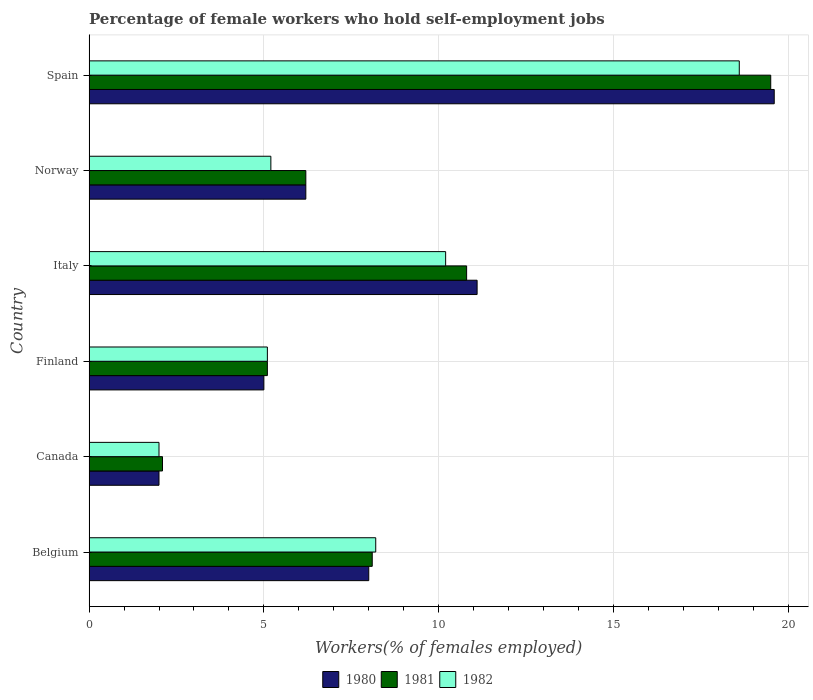How many bars are there on the 4th tick from the top?
Your answer should be compact. 3. How many bars are there on the 2nd tick from the bottom?
Offer a very short reply. 3. What is the label of the 1st group of bars from the top?
Your answer should be compact. Spain. What is the percentage of self-employed female workers in 1980 in Norway?
Provide a short and direct response. 6.2. Across all countries, what is the maximum percentage of self-employed female workers in 1980?
Make the answer very short. 19.6. Across all countries, what is the minimum percentage of self-employed female workers in 1981?
Provide a short and direct response. 2.1. In which country was the percentage of self-employed female workers in 1982 maximum?
Ensure brevity in your answer.  Spain. In which country was the percentage of self-employed female workers in 1981 minimum?
Make the answer very short. Canada. What is the total percentage of self-employed female workers in 1982 in the graph?
Provide a short and direct response. 49.3. What is the difference between the percentage of self-employed female workers in 1980 in Canada and that in Italy?
Provide a succinct answer. -9.1. What is the difference between the percentage of self-employed female workers in 1981 in Spain and the percentage of self-employed female workers in 1982 in Norway?
Your answer should be compact. 14.3. What is the average percentage of self-employed female workers in 1981 per country?
Provide a succinct answer. 8.63. In how many countries, is the percentage of self-employed female workers in 1981 greater than 4 %?
Your response must be concise. 5. What is the ratio of the percentage of self-employed female workers in 1982 in Italy to that in Norway?
Make the answer very short. 1.96. Is the percentage of self-employed female workers in 1981 in Finland less than that in Spain?
Your answer should be compact. Yes. What is the difference between the highest and the second highest percentage of self-employed female workers in 1981?
Provide a short and direct response. 8.7. What is the difference between the highest and the lowest percentage of self-employed female workers in 1982?
Your answer should be very brief. 16.6. In how many countries, is the percentage of self-employed female workers in 1982 greater than the average percentage of self-employed female workers in 1982 taken over all countries?
Your answer should be compact. 2. Is the sum of the percentage of self-employed female workers in 1982 in Norway and Spain greater than the maximum percentage of self-employed female workers in 1981 across all countries?
Keep it short and to the point. Yes. What does the 2nd bar from the top in Italy represents?
Make the answer very short. 1981. What does the 3rd bar from the bottom in Norway represents?
Make the answer very short. 1982. How many countries are there in the graph?
Make the answer very short. 6. Are the values on the major ticks of X-axis written in scientific E-notation?
Offer a terse response. No. Does the graph contain grids?
Make the answer very short. Yes. How many legend labels are there?
Your answer should be compact. 3. How are the legend labels stacked?
Provide a short and direct response. Horizontal. What is the title of the graph?
Your answer should be very brief. Percentage of female workers who hold self-employment jobs. Does "2009" appear as one of the legend labels in the graph?
Provide a succinct answer. No. What is the label or title of the X-axis?
Offer a terse response. Workers(% of females employed). What is the label or title of the Y-axis?
Ensure brevity in your answer.  Country. What is the Workers(% of females employed) of 1981 in Belgium?
Your response must be concise. 8.1. What is the Workers(% of females employed) in 1982 in Belgium?
Give a very brief answer. 8.2. What is the Workers(% of females employed) in 1980 in Canada?
Your response must be concise. 2. What is the Workers(% of females employed) in 1981 in Canada?
Offer a terse response. 2.1. What is the Workers(% of females employed) in 1981 in Finland?
Provide a succinct answer. 5.1. What is the Workers(% of females employed) in 1982 in Finland?
Provide a succinct answer. 5.1. What is the Workers(% of females employed) of 1980 in Italy?
Your answer should be compact. 11.1. What is the Workers(% of females employed) in 1981 in Italy?
Ensure brevity in your answer.  10.8. What is the Workers(% of females employed) of 1982 in Italy?
Offer a very short reply. 10.2. What is the Workers(% of females employed) of 1980 in Norway?
Ensure brevity in your answer.  6.2. What is the Workers(% of females employed) of 1981 in Norway?
Provide a short and direct response. 6.2. What is the Workers(% of females employed) in 1982 in Norway?
Ensure brevity in your answer.  5.2. What is the Workers(% of females employed) in 1980 in Spain?
Offer a terse response. 19.6. What is the Workers(% of females employed) in 1981 in Spain?
Provide a short and direct response. 19.5. What is the Workers(% of females employed) in 1982 in Spain?
Provide a short and direct response. 18.6. Across all countries, what is the maximum Workers(% of females employed) in 1980?
Make the answer very short. 19.6. Across all countries, what is the maximum Workers(% of females employed) in 1982?
Your answer should be very brief. 18.6. Across all countries, what is the minimum Workers(% of females employed) in 1981?
Make the answer very short. 2.1. Across all countries, what is the minimum Workers(% of females employed) in 1982?
Give a very brief answer. 2. What is the total Workers(% of females employed) in 1980 in the graph?
Keep it short and to the point. 51.9. What is the total Workers(% of females employed) in 1981 in the graph?
Ensure brevity in your answer.  51.8. What is the total Workers(% of females employed) of 1982 in the graph?
Your answer should be compact. 49.3. What is the difference between the Workers(% of females employed) of 1982 in Belgium and that in Canada?
Keep it short and to the point. 6.2. What is the difference between the Workers(% of females employed) of 1982 in Belgium and that in Finland?
Offer a very short reply. 3.1. What is the difference between the Workers(% of females employed) of 1981 in Belgium and that in Italy?
Give a very brief answer. -2.7. What is the difference between the Workers(% of females employed) in 1982 in Belgium and that in Italy?
Your answer should be very brief. -2. What is the difference between the Workers(% of females employed) in 1980 in Belgium and that in Norway?
Make the answer very short. 1.8. What is the difference between the Workers(% of females employed) in 1980 in Belgium and that in Spain?
Provide a short and direct response. -11.6. What is the difference between the Workers(% of females employed) in 1981 in Belgium and that in Spain?
Ensure brevity in your answer.  -11.4. What is the difference between the Workers(% of females employed) in 1982 in Belgium and that in Spain?
Your answer should be compact. -10.4. What is the difference between the Workers(% of females employed) in 1980 in Canada and that in Finland?
Offer a very short reply. -3. What is the difference between the Workers(% of females employed) in 1982 in Canada and that in Finland?
Give a very brief answer. -3.1. What is the difference between the Workers(% of females employed) in 1981 in Canada and that in Italy?
Offer a very short reply. -8.7. What is the difference between the Workers(% of females employed) in 1982 in Canada and that in Italy?
Keep it short and to the point. -8.2. What is the difference between the Workers(% of females employed) of 1982 in Canada and that in Norway?
Make the answer very short. -3.2. What is the difference between the Workers(% of females employed) in 1980 in Canada and that in Spain?
Make the answer very short. -17.6. What is the difference between the Workers(% of females employed) in 1981 in Canada and that in Spain?
Keep it short and to the point. -17.4. What is the difference between the Workers(% of females employed) in 1982 in Canada and that in Spain?
Your response must be concise. -16.6. What is the difference between the Workers(% of females employed) in 1981 in Finland and that in Italy?
Your answer should be very brief. -5.7. What is the difference between the Workers(% of females employed) of 1982 in Finland and that in Italy?
Offer a very short reply. -5.1. What is the difference between the Workers(% of females employed) of 1981 in Finland and that in Norway?
Give a very brief answer. -1.1. What is the difference between the Workers(% of females employed) in 1982 in Finland and that in Norway?
Offer a very short reply. -0.1. What is the difference between the Workers(% of females employed) of 1980 in Finland and that in Spain?
Provide a short and direct response. -14.6. What is the difference between the Workers(% of females employed) in 1981 in Finland and that in Spain?
Give a very brief answer. -14.4. What is the difference between the Workers(% of females employed) of 1982 in Finland and that in Spain?
Make the answer very short. -13.5. What is the difference between the Workers(% of females employed) in 1982 in Italy and that in Norway?
Give a very brief answer. 5. What is the difference between the Workers(% of females employed) in 1982 in Italy and that in Spain?
Offer a very short reply. -8.4. What is the difference between the Workers(% of females employed) in 1981 in Norway and that in Spain?
Give a very brief answer. -13.3. What is the difference between the Workers(% of females employed) of 1982 in Norway and that in Spain?
Ensure brevity in your answer.  -13.4. What is the difference between the Workers(% of females employed) in 1981 in Belgium and the Workers(% of females employed) in 1982 in Canada?
Provide a succinct answer. 6.1. What is the difference between the Workers(% of females employed) of 1981 in Belgium and the Workers(% of females employed) of 1982 in Finland?
Give a very brief answer. 3. What is the difference between the Workers(% of females employed) of 1980 in Belgium and the Workers(% of females employed) of 1981 in Italy?
Make the answer very short. -2.8. What is the difference between the Workers(% of females employed) of 1980 in Belgium and the Workers(% of females employed) of 1982 in Italy?
Your response must be concise. -2.2. What is the difference between the Workers(% of females employed) of 1981 in Belgium and the Workers(% of females employed) of 1982 in Italy?
Offer a terse response. -2.1. What is the difference between the Workers(% of females employed) in 1980 in Belgium and the Workers(% of females employed) in 1982 in Norway?
Provide a succinct answer. 2.8. What is the difference between the Workers(% of females employed) of 1980 in Belgium and the Workers(% of females employed) of 1982 in Spain?
Provide a succinct answer. -10.6. What is the difference between the Workers(% of females employed) in 1981 in Belgium and the Workers(% of females employed) in 1982 in Spain?
Offer a very short reply. -10.5. What is the difference between the Workers(% of females employed) of 1980 in Canada and the Workers(% of females employed) of 1982 in Italy?
Provide a short and direct response. -8.2. What is the difference between the Workers(% of females employed) in 1981 in Canada and the Workers(% of females employed) in 1982 in Italy?
Your answer should be very brief. -8.1. What is the difference between the Workers(% of females employed) of 1980 in Canada and the Workers(% of females employed) of 1981 in Norway?
Provide a succinct answer. -4.2. What is the difference between the Workers(% of females employed) of 1980 in Canada and the Workers(% of females employed) of 1982 in Norway?
Provide a succinct answer. -3.2. What is the difference between the Workers(% of females employed) in 1980 in Canada and the Workers(% of females employed) in 1981 in Spain?
Your answer should be compact. -17.5. What is the difference between the Workers(% of females employed) of 1980 in Canada and the Workers(% of females employed) of 1982 in Spain?
Provide a succinct answer. -16.6. What is the difference between the Workers(% of females employed) of 1981 in Canada and the Workers(% of females employed) of 1982 in Spain?
Provide a short and direct response. -16.5. What is the difference between the Workers(% of females employed) of 1980 in Finland and the Workers(% of females employed) of 1981 in Italy?
Offer a terse response. -5.8. What is the difference between the Workers(% of females employed) in 1980 in Finland and the Workers(% of females employed) in 1981 in Norway?
Your answer should be very brief. -1.2. What is the difference between the Workers(% of females employed) in 1981 in Finland and the Workers(% of females employed) in 1982 in Norway?
Your answer should be very brief. -0.1. What is the difference between the Workers(% of females employed) of 1980 in Finland and the Workers(% of females employed) of 1981 in Spain?
Your answer should be compact. -14.5. What is the difference between the Workers(% of females employed) in 1981 in Finland and the Workers(% of females employed) in 1982 in Spain?
Ensure brevity in your answer.  -13.5. What is the difference between the Workers(% of females employed) of 1980 in Italy and the Workers(% of females employed) of 1981 in Norway?
Your answer should be very brief. 4.9. What is the difference between the Workers(% of females employed) in 1980 in Italy and the Workers(% of females employed) in 1982 in Norway?
Your response must be concise. 5.9. What is the difference between the Workers(% of females employed) of 1981 in Italy and the Workers(% of females employed) of 1982 in Norway?
Your response must be concise. 5.6. What is the difference between the Workers(% of females employed) in 1980 in Italy and the Workers(% of females employed) in 1982 in Spain?
Your answer should be compact. -7.5. What is the difference between the Workers(% of females employed) of 1980 in Norway and the Workers(% of females employed) of 1981 in Spain?
Your answer should be compact. -13.3. What is the difference between the Workers(% of females employed) of 1981 in Norway and the Workers(% of females employed) of 1982 in Spain?
Provide a short and direct response. -12.4. What is the average Workers(% of females employed) of 1980 per country?
Your answer should be compact. 8.65. What is the average Workers(% of females employed) in 1981 per country?
Keep it short and to the point. 8.63. What is the average Workers(% of females employed) in 1982 per country?
Provide a short and direct response. 8.22. What is the difference between the Workers(% of females employed) of 1981 and Workers(% of females employed) of 1982 in Belgium?
Provide a succinct answer. -0.1. What is the difference between the Workers(% of females employed) in 1980 and Workers(% of females employed) in 1981 in Canada?
Your answer should be compact. -0.1. What is the difference between the Workers(% of females employed) of 1980 and Workers(% of females employed) of 1982 in Canada?
Give a very brief answer. 0. What is the difference between the Workers(% of females employed) of 1981 and Workers(% of females employed) of 1982 in Canada?
Ensure brevity in your answer.  0.1. What is the difference between the Workers(% of females employed) in 1980 and Workers(% of females employed) in 1981 in Finland?
Ensure brevity in your answer.  -0.1. What is the difference between the Workers(% of females employed) of 1980 and Workers(% of females employed) of 1982 in Finland?
Your answer should be very brief. -0.1. What is the difference between the Workers(% of females employed) in 1981 and Workers(% of females employed) in 1982 in Finland?
Your answer should be compact. 0. What is the difference between the Workers(% of females employed) in 1980 and Workers(% of females employed) in 1981 in Italy?
Offer a very short reply. 0.3. What is the difference between the Workers(% of females employed) of 1981 and Workers(% of females employed) of 1982 in Italy?
Your answer should be very brief. 0.6. What is the difference between the Workers(% of females employed) in 1980 and Workers(% of females employed) in 1982 in Spain?
Offer a very short reply. 1. What is the ratio of the Workers(% of females employed) in 1981 in Belgium to that in Canada?
Your answer should be very brief. 3.86. What is the ratio of the Workers(% of females employed) in 1981 in Belgium to that in Finland?
Provide a succinct answer. 1.59. What is the ratio of the Workers(% of females employed) of 1982 in Belgium to that in Finland?
Your response must be concise. 1.61. What is the ratio of the Workers(% of females employed) in 1980 in Belgium to that in Italy?
Provide a short and direct response. 0.72. What is the ratio of the Workers(% of females employed) in 1981 in Belgium to that in Italy?
Keep it short and to the point. 0.75. What is the ratio of the Workers(% of females employed) of 1982 in Belgium to that in Italy?
Keep it short and to the point. 0.8. What is the ratio of the Workers(% of females employed) in 1980 in Belgium to that in Norway?
Keep it short and to the point. 1.29. What is the ratio of the Workers(% of females employed) in 1981 in Belgium to that in Norway?
Your response must be concise. 1.31. What is the ratio of the Workers(% of females employed) in 1982 in Belgium to that in Norway?
Ensure brevity in your answer.  1.58. What is the ratio of the Workers(% of females employed) of 1980 in Belgium to that in Spain?
Offer a terse response. 0.41. What is the ratio of the Workers(% of females employed) of 1981 in Belgium to that in Spain?
Your response must be concise. 0.42. What is the ratio of the Workers(% of females employed) of 1982 in Belgium to that in Spain?
Provide a short and direct response. 0.44. What is the ratio of the Workers(% of females employed) of 1980 in Canada to that in Finland?
Make the answer very short. 0.4. What is the ratio of the Workers(% of females employed) in 1981 in Canada to that in Finland?
Offer a terse response. 0.41. What is the ratio of the Workers(% of females employed) in 1982 in Canada to that in Finland?
Give a very brief answer. 0.39. What is the ratio of the Workers(% of females employed) of 1980 in Canada to that in Italy?
Your response must be concise. 0.18. What is the ratio of the Workers(% of females employed) of 1981 in Canada to that in Italy?
Make the answer very short. 0.19. What is the ratio of the Workers(% of females employed) in 1982 in Canada to that in Italy?
Offer a terse response. 0.2. What is the ratio of the Workers(% of females employed) of 1980 in Canada to that in Norway?
Make the answer very short. 0.32. What is the ratio of the Workers(% of females employed) of 1981 in Canada to that in Norway?
Your answer should be compact. 0.34. What is the ratio of the Workers(% of females employed) of 1982 in Canada to that in Norway?
Offer a very short reply. 0.38. What is the ratio of the Workers(% of females employed) of 1980 in Canada to that in Spain?
Your answer should be compact. 0.1. What is the ratio of the Workers(% of females employed) of 1981 in Canada to that in Spain?
Offer a very short reply. 0.11. What is the ratio of the Workers(% of females employed) in 1982 in Canada to that in Spain?
Provide a short and direct response. 0.11. What is the ratio of the Workers(% of females employed) of 1980 in Finland to that in Italy?
Your answer should be very brief. 0.45. What is the ratio of the Workers(% of females employed) in 1981 in Finland to that in Italy?
Your answer should be very brief. 0.47. What is the ratio of the Workers(% of females employed) of 1982 in Finland to that in Italy?
Your answer should be compact. 0.5. What is the ratio of the Workers(% of females employed) in 1980 in Finland to that in Norway?
Your answer should be compact. 0.81. What is the ratio of the Workers(% of females employed) of 1981 in Finland to that in Norway?
Give a very brief answer. 0.82. What is the ratio of the Workers(% of females employed) of 1982 in Finland to that in Norway?
Offer a very short reply. 0.98. What is the ratio of the Workers(% of females employed) in 1980 in Finland to that in Spain?
Offer a very short reply. 0.26. What is the ratio of the Workers(% of females employed) of 1981 in Finland to that in Spain?
Ensure brevity in your answer.  0.26. What is the ratio of the Workers(% of females employed) of 1982 in Finland to that in Spain?
Your answer should be very brief. 0.27. What is the ratio of the Workers(% of females employed) in 1980 in Italy to that in Norway?
Give a very brief answer. 1.79. What is the ratio of the Workers(% of females employed) in 1981 in Italy to that in Norway?
Your response must be concise. 1.74. What is the ratio of the Workers(% of females employed) in 1982 in Italy to that in Norway?
Ensure brevity in your answer.  1.96. What is the ratio of the Workers(% of females employed) in 1980 in Italy to that in Spain?
Your response must be concise. 0.57. What is the ratio of the Workers(% of females employed) of 1981 in Italy to that in Spain?
Provide a short and direct response. 0.55. What is the ratio of the Workers(% of females employed) in 1982 in Italy to that in Spain?
Provide a short and direct response. 0.55. What is the ratio of the Workers(% of females employed) in 1980 in Norway to that in Spain?
Give a very brief answer. 0.32. What is the ratio of the Workers(% of females employed) of 1981 in Norway to that in Spain?
Provide a succinct answer. 0.32. What is the ratio of the Workers(% of females employed) of 1982 in Norway to that in Spain?
Offer a very short reply. 0.28. What is the difference between the highest and the lowest Workers(% of females employed) in 1981?
Offer a very short reply. 17.4. What is the difference between the highest and the lowest Workers(% of females employed) of 1982?
Your answer should be compact. 16.6. 